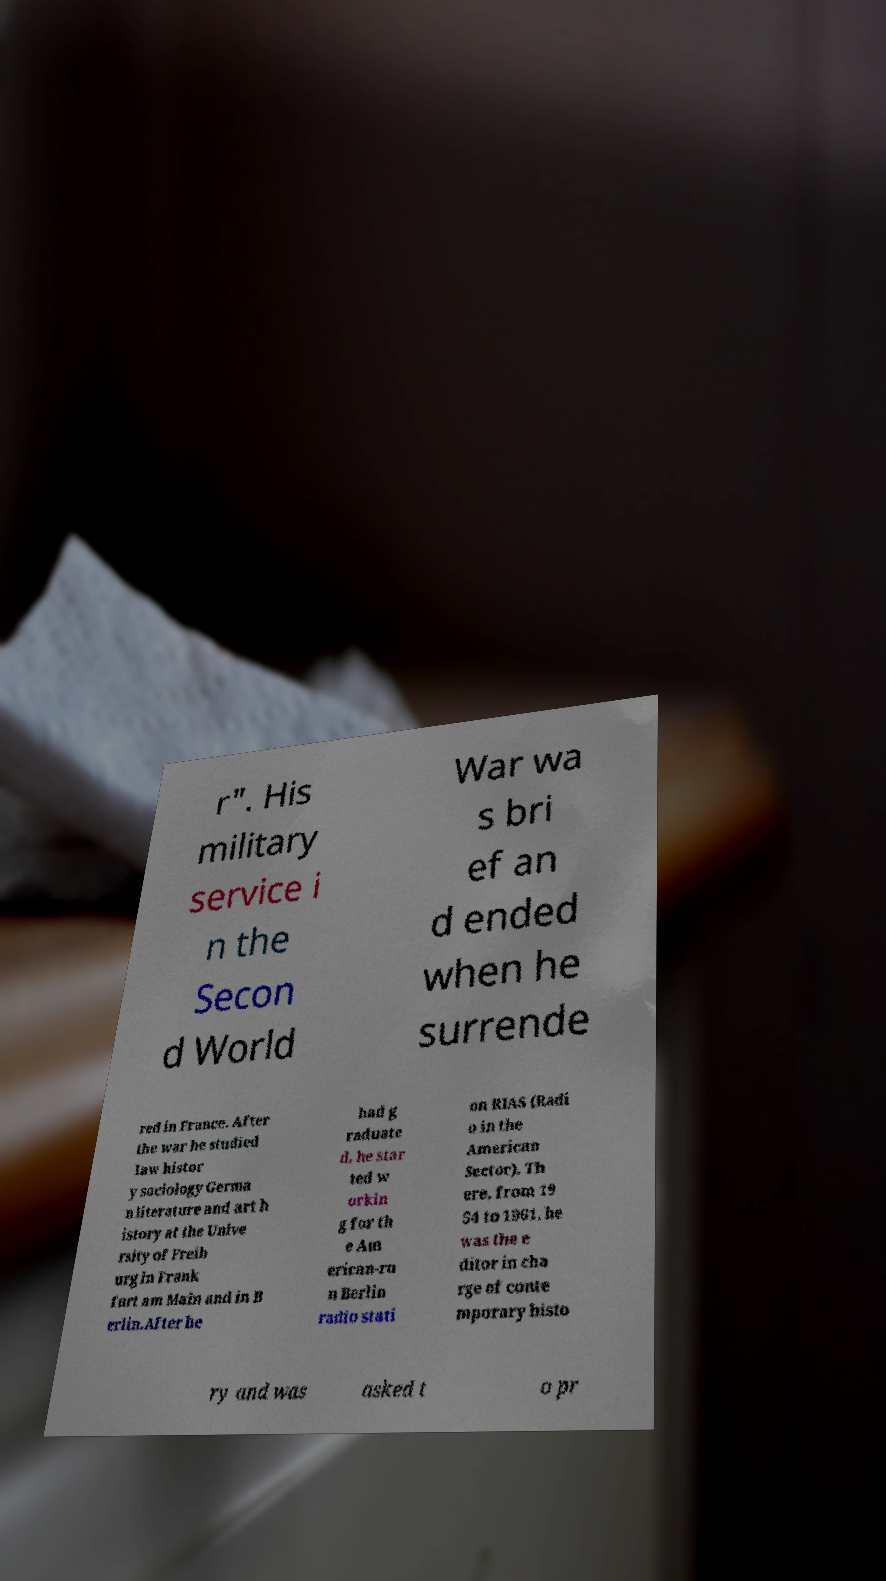Can you read and provide the text displayed in the image?This photo seems to have some interesting text. Can you extract and type it out for me? r". His military service i n the Secon d World War wa s bri ef an d ended when he surrende red in France. After the war he studied law histor y sociology Germa n literature and art h istory at the Unive rsity of Freib urg in Frank furt am Main and in B erlin.After he had g raduate d, he star ted w orkin g for th e Am erican-ru n Berlin radio stati on RIAS (Radi o in the American Sector). Th ere, from 19 54 to 1961, he was the e ditor in cha rge of conte mporary histo ry and was asked t o pr 